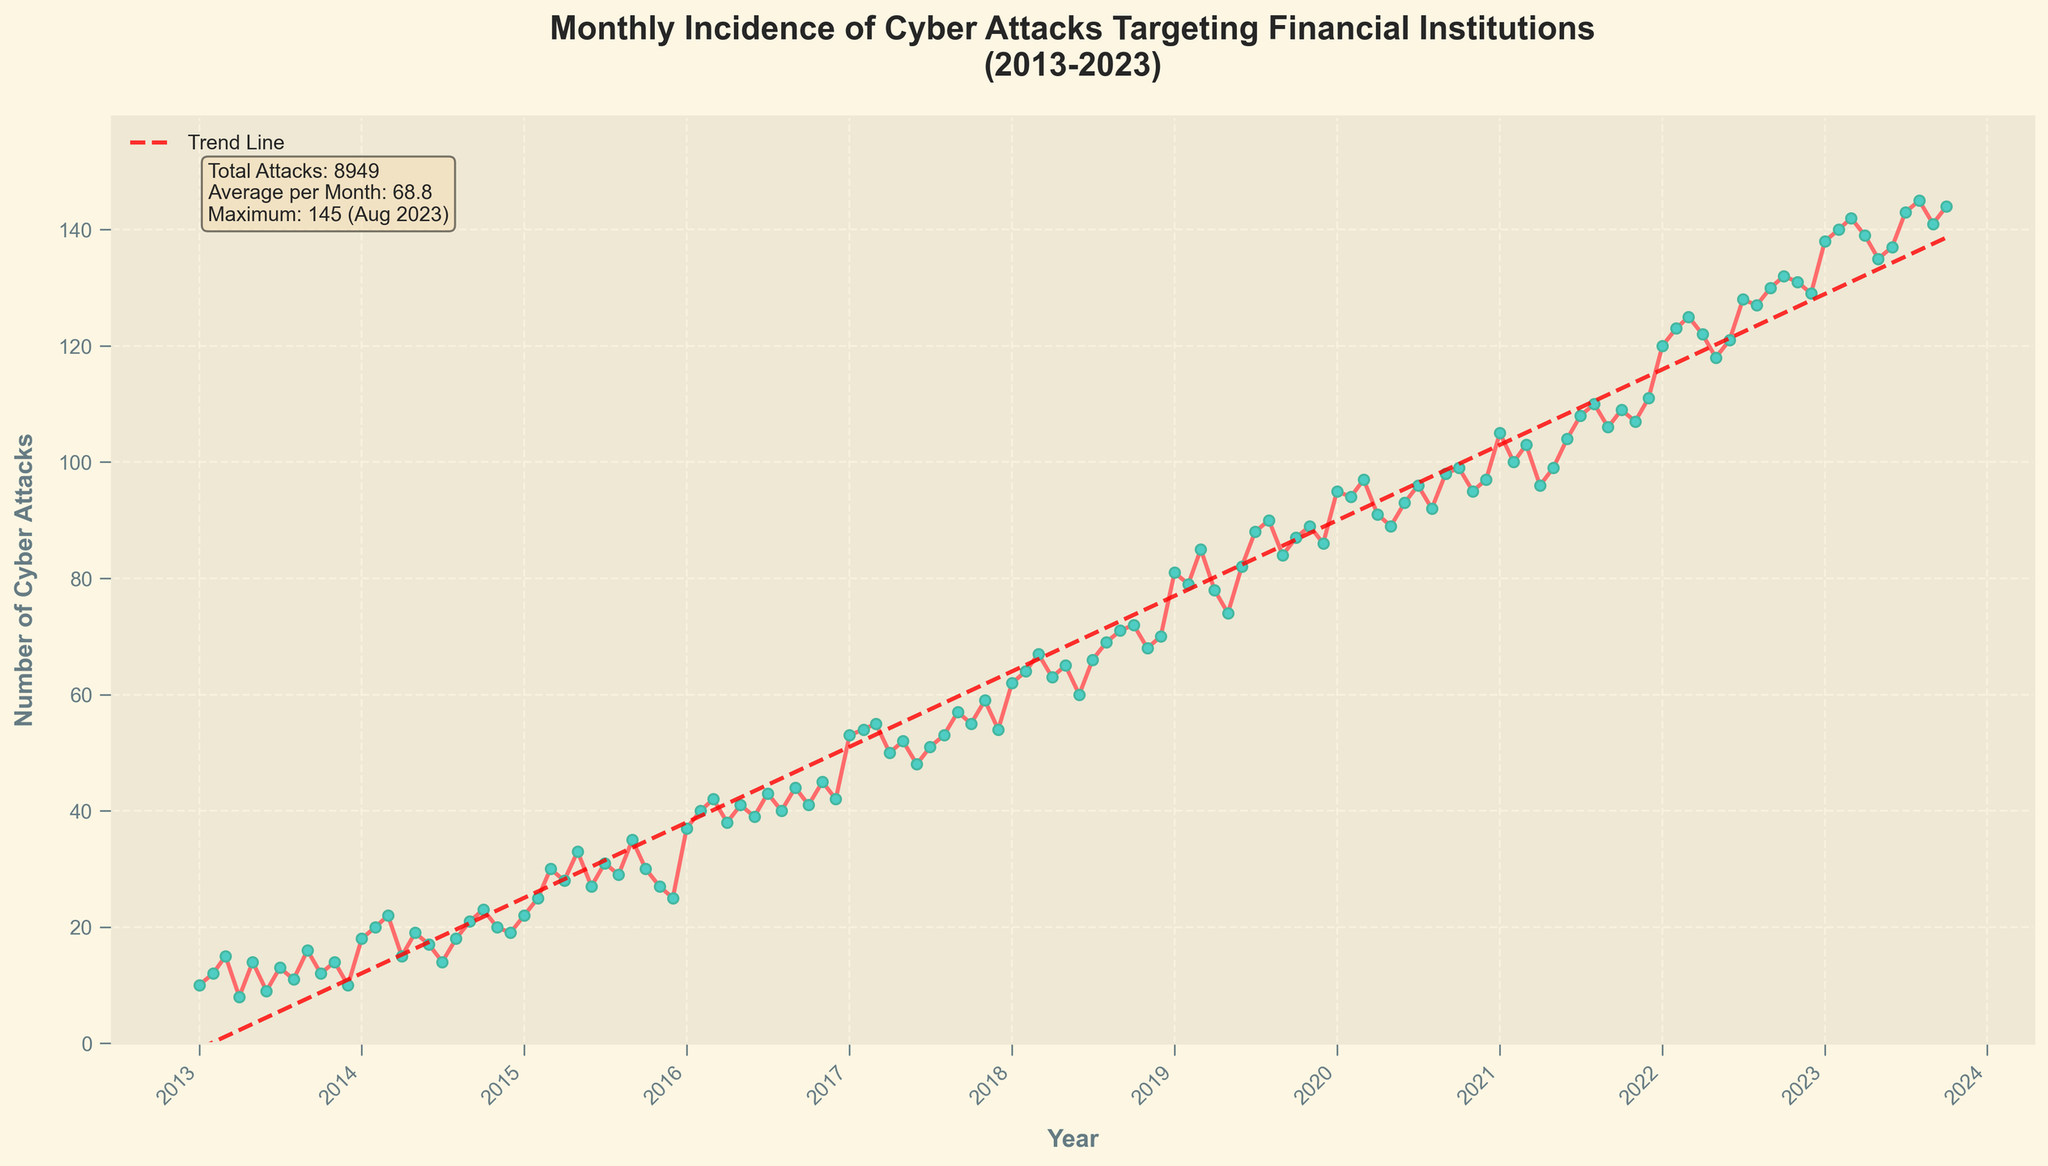What's the title of the figure? The title of the figure is located at the top center of the plot and it summarizes the data being presented. The title reads "Monthly Incidence of Cyber Attacks Targeting Financial Institutions (2013-2023)".
Answer: Monthly Incidence of Cyber Attacks Targeting Financial Institutions (2013-2023) What is the lowest number of cyber attacks reported in a month, and when did it occur? To find the lowest number of cyber attacks, we look for the point on the y-axis with the smallest value, which is 8. This occurred in April 2013.
Answer: 8, April 2013 How many cyber attacks were reported in total during the period covered by the plot? The total number of cyber attacks is summarized in the text box found within the plot. The text box notes that the total number of attacks is 9,546.
Answer: 9,546 On average, how many cyber attacks occurred per month? The average number of cyber attacks per month is provided in the text box within the plot. The average is calculated by dividing the total number of attacks (9,546) by the number of months (11*12 + 10 = 130), which gives approximately 73.4.
Answer: 73.4 In what month and year did the maximum number of cyber attacks occur? By referring to the text box within the plot, it is stated that the maximum number of attacks, which is 145, occurred in August 2023.
Answer: August 2023 How did the number of cyber attacks in 2019 compare to that in 2015? To compare the number of cyber attacks in 2019 and 2015, examine the y-values for each year. The monthly data points indicate that the number of attacks in 2019 steadily increased and reached up to around 90, while in 2015, the number was generally lower and peaked around 35.
Answer: Higher in 2019 Describe the trend of cyber attacks from 2013 to 2023. The trend of cyber attacks is indicated by the red dashed trend line in the plot. The trend shows a steady increase over the years, indicating that the number of cyber attacks has generally been rising from 2013 to 2023.
Answer: Steady increase Which year experienced the sharpest increase in cyber attacks? Observing the slope of the line connecting the data points, 2021 shows a sharp increase as the attacks jump significantly from January to December 2021.
Answer: 2021 How many months reported over 100 cyber attacks within the time span? By counting the number of data points that pass the 100 mark on the y-axis, it is noticeable that it starts surpassing 100 from around January 2021 until October 2023, which involves about 35 months.
Answer: 35 Could you explain the general pattern in the incidence of cyber attacks during the summer months compared to the winter months? Observing the repeating monthly patterns, it appears that cyber attacks tend to peak during the summer months (June to August) and then slightly dip during the winter months (December to February), although they are high overall.
Answer: Peaks in summer, dips in winter 